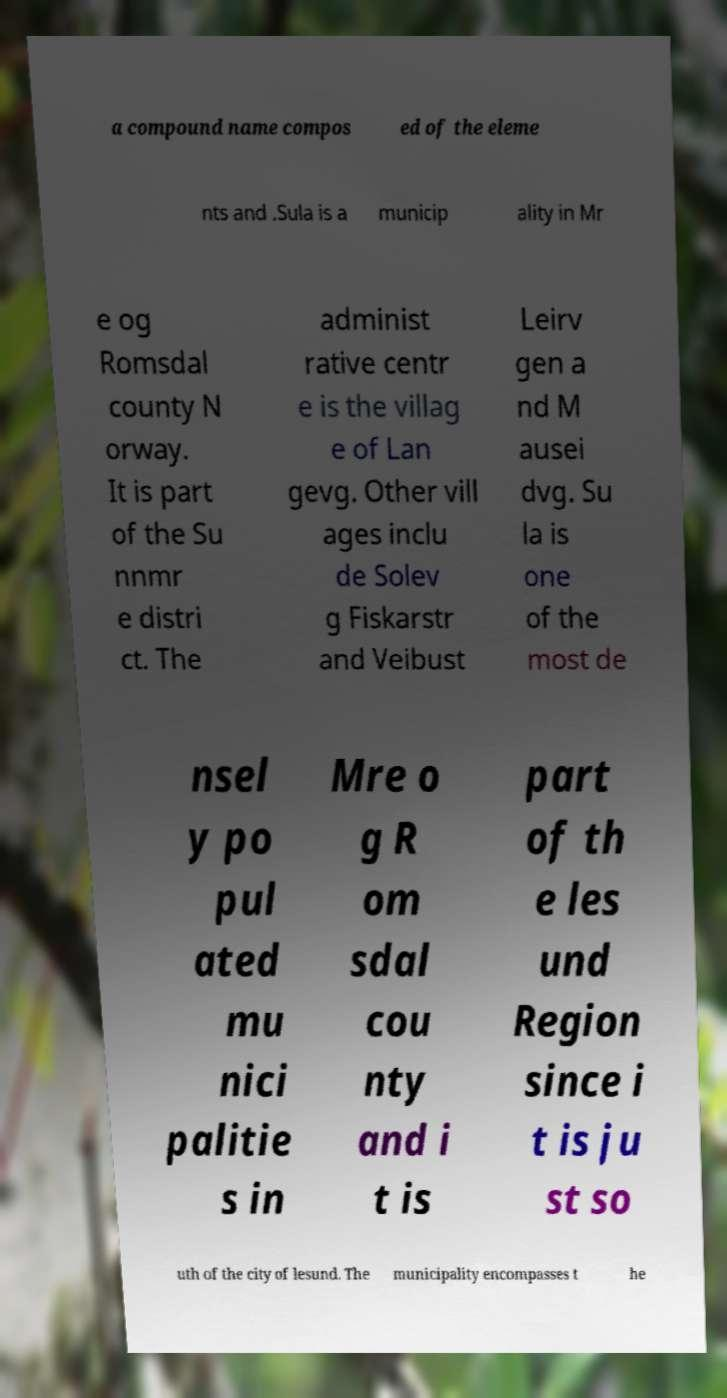For documentation purposes, I need the text within this image transcribed. Could you provide that? a compound name compos ed of the eleme nts and .Sula is a municip ality in Mr e og Romsdal county N orway. It is part of the Su nnmr e distri ct. The administ rative centr e is the villag e of Lan gevg. Other vill ages inclu de Solev g Fiskarstr and Veibust Leirv gen a nd M ausei dvg. Su la is one of the most de nsel y po pul ated mu nici palitie s in Mre o g R om sdal cou nty and i t is part of th e les und Region since i t is ju st so uth of the city of lesund. The municipality encompasses t he 